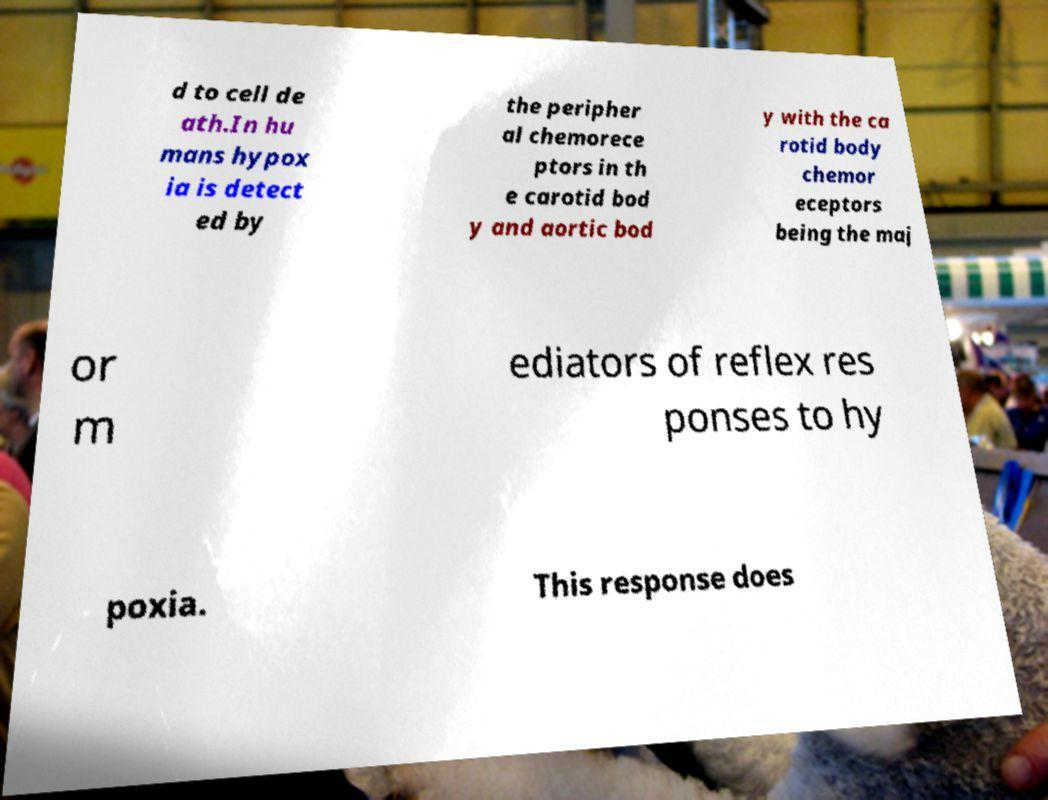What messages or text are displayed in this image? I need them in a readable, typed format. d to cell de ath.In hu mans hypox ia is detect ed by the peripher al chemorece ptors in th e carotid bod y and aortic bod y with the ca rotid body chemor eceptors being the maj or m ediators of reflex res ponses to hy poxia. This response does 